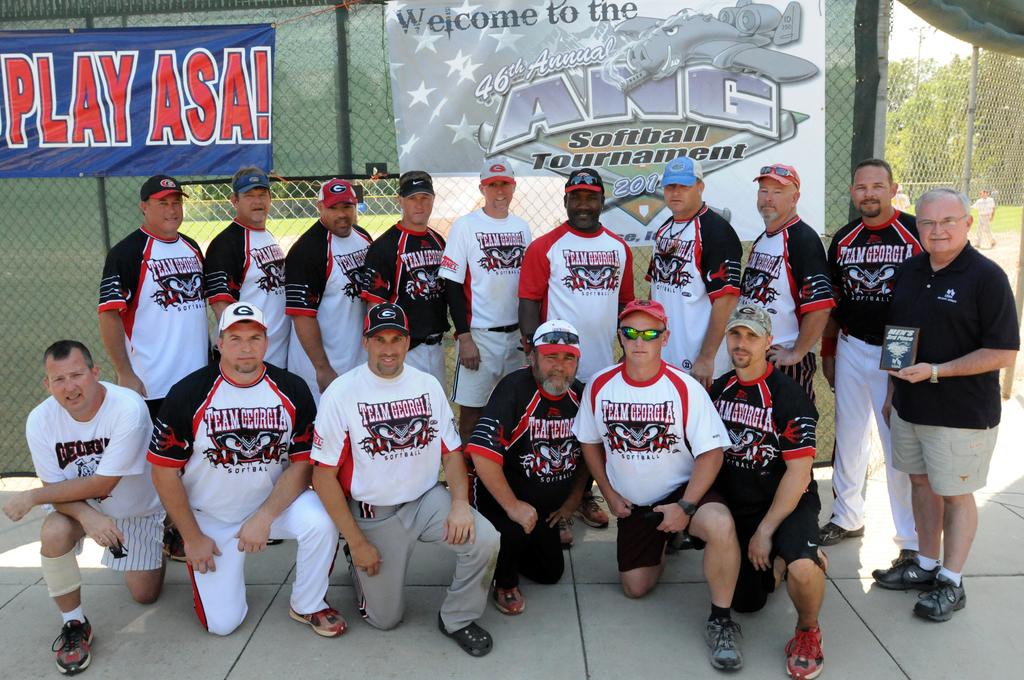What is the name of the tournament?
Offer a terse response. Ang softball tournament. What team do the players represent?
Your response must be concise. Team georgia. 